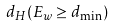<formula> <loc_0><loc_0><loc_500><loc_500>d _ { H } ( E _ { w } \geq d _ { \min } )</formula> 